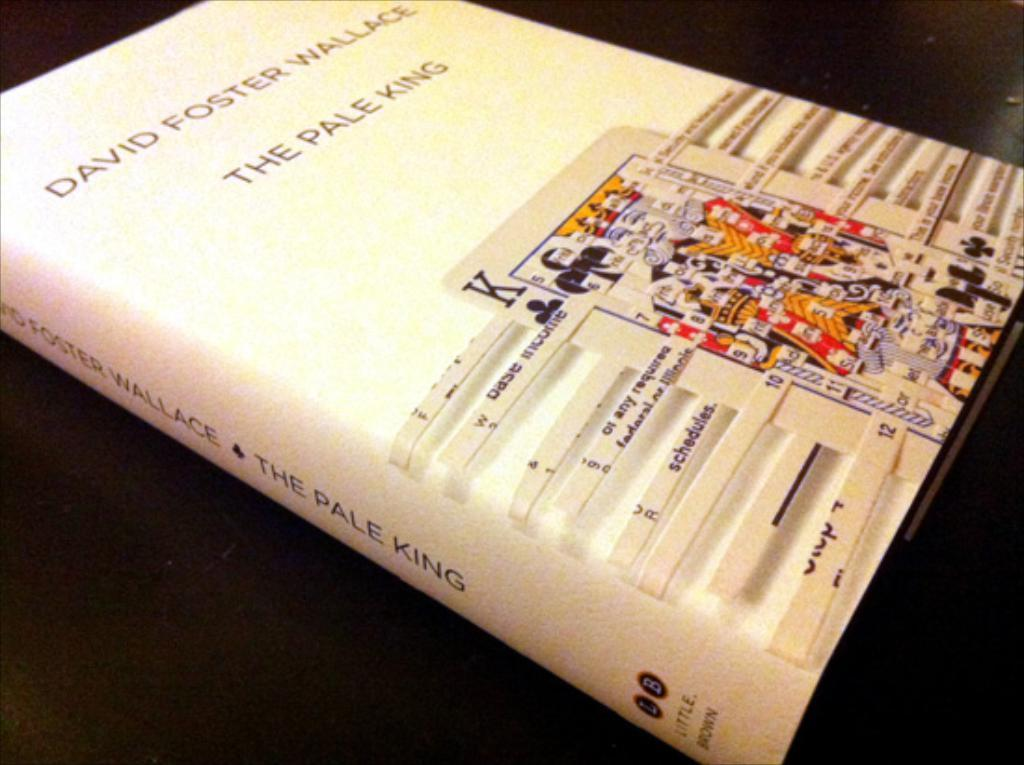<image>
Summarize the visual content of the image. A playing card image decorates the cover of David Foster Wallace's "Pale King" book. 